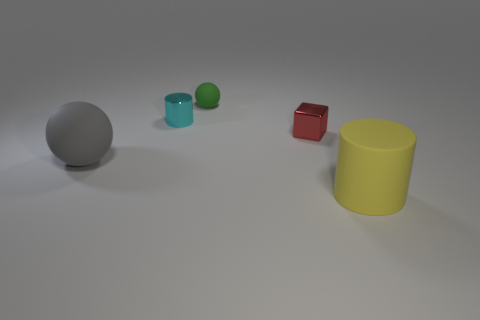If we imagine these objects in a real-life setting, what could their sizes tell us about their potential uses? If we projected these objects into a real-world context, we could infer various potential uses based on their sizes. The large grey sphere could represent a sports ball, such as a soccer or basketball, depending on its actual size and material. The small green sphere might be similar to a decorative object or a small ball used in indoor games. The tiny cyan cube could be a child's toy block, suitable for stacking and building. The yellow cylinder, due to its height and width, might be a storage container or a simplistic representation of a piece of furniture, like a stool. Their uses could range from functional to decorative, all depending on the actual scale and the materials they represent. 